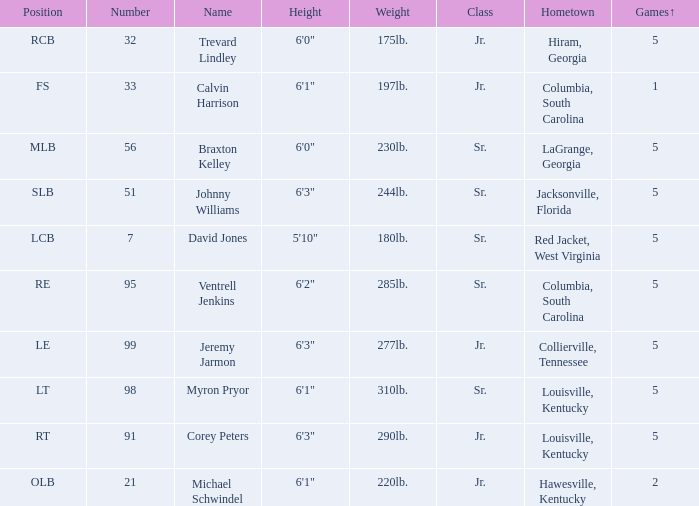How many players were 6'1" and from Columbia, South Carolina? 1.0. Would you be able to parse every entry in this table? {'header': ['Position', 'Number', 'Name', 'Height', 'Weight', 'Class', 'Hometown', 'Games↑'], 'rows': [['RCB', '32', 'Trevard Lindley', '6\'0"', '175lb.', 'Jr.', 'Hiram, Georgia', '5'], ['FS', '33', 'Calvin Harrison', '6\'1"', '197lb.', 'Jr.', 'Columbia, South Carolina', '1'], ['MLB', '56', 'Braxton Kelley', '6\'0"', '230lb.', 'Sr.', 'LaGrange, Georgia', '5'], ['SLB', '51', 'Johnny Williams', '6\'3"', '244lb.', 'Sr.', 'Jacksonville, Florida', '5'], ['LCB', '7', 'David Jones', '5\'10"', '180lb.', 'Sr.', 'Red Jacket, West Virginia', '5'], ['RE', '95', 'Ventrell Jenkins', '6\'2"', '285lb.', 'Sr.', 'Columbia, South Carolina', '5'], ['LE', '99', 'Jeremy Jarmon', '6\'3"', '277lb.', 'Jr.', 'Collierville, Tennessee', '5'], ['LT', '98', 'Myron Pryor', '6\'1"', '310lb.', 'Sr.', 'Louisville, Kentucky', '5'], ['RT', '91', 'Corey Peters', '6\'3"', '290lb.', 'Jr.', 'Louisville, Kentucky', '5'], ['OLB', '21', 'Michael Schwindel', '6\'1"', '220lb.', 'Jr.', 'Hawesville, Kentucky', '2']]} 